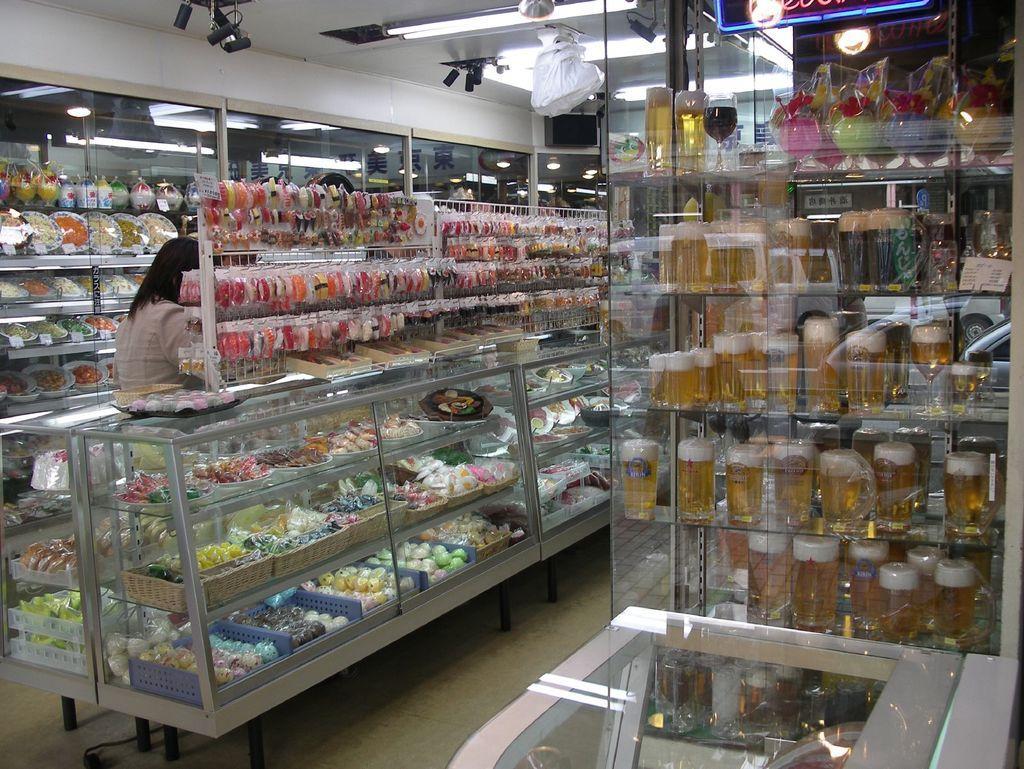Can you describe this image briefly? The image is taken in a store. In the image there are glass shelves and racks. On the right there are glasses filled with beers and there are other food items. In the center of the picture there are food items, toys, key chains and woman. In the background there are glass windows, food items, packed and other objects. At the top there are cameras, lights and other objects. 